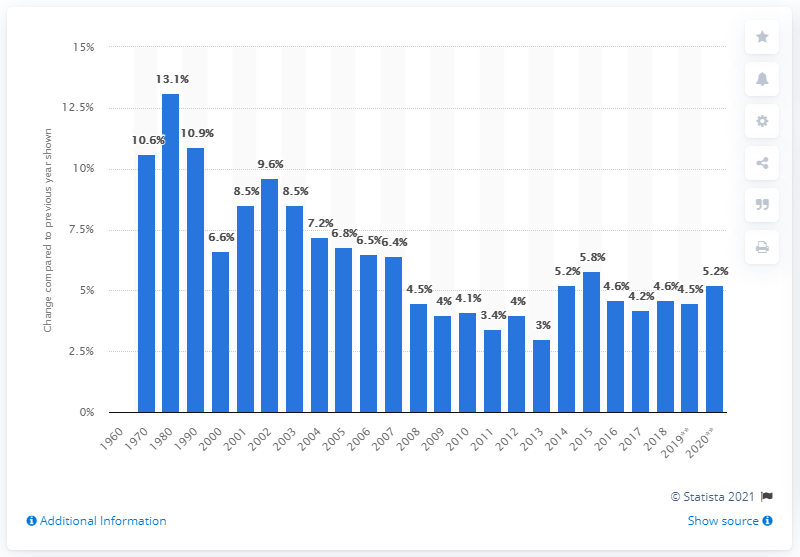Identify some key points in this picture. The expected increase in health expenditure in the United States for the year 2020 was projected to be 5.2%. 